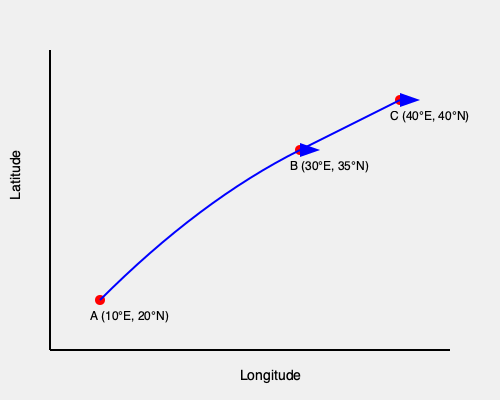As the director of a humanitarian organization, you're planning a mission to assist refugees along their migration route. The map shows three key locations: A (10°E, 20°N), B (30°E, 35°N), and C (40°E, 40°N). What is the total distance traveled by refugees following this route, assuming they move in straight lines between these points? (Use the Haversine formula and assume the Earth's radius is 6371 km. Round your answer to the nearest kilometer.) To solve this problem, we need to calculate the distances between points A and B, and then B and C using the Haversine formula. Then, we'll sum these distances to get the total route length.

The Haversine formula is:

$$d = 2r \arcsin(\sqrt{\sin^2(\frac{\Delta\phi}{2}) + \cos\phi_1 \cos\phi_2 \sin^2(\frac{\Delta\lambda}{2})})$$

Where:
- $r$ is the Earth's radius (6371 km)
- $\phi$ is latitude in radians
- $\lambda$ is longitude in radians

Step 1: Convert all coordinates from degrees to radians
A: (10°E, 20°N) → (0.1745 rad, 0.3491 rad)
B: (30°E, 35°N) → (0.5236 rad, 0.6109 rad)
C: (40°E, 40°N) → (0.6981 rad, 0.6981 rad)

Step 2: Calculate distance from A to B
$\Delta\phi = 0.6109 - 0.3491 = 0.2618$
$\Delta\lambda = 0.5236 - 0.1745 = 0.3491$

Applying the Haversine formula:
$$d_{AB} = 2 * 6371 * \arcsin(\sqrt{\sin^2(0.1309) + \cos(0.3491) \cos(0.6109) \sin^2(0.17455)})$$
$$d_{AB} \approx 2588.39 \text{ km}$$

Step 3: Calculate distance from B to C
$\Delta\phi = 0.6981 - 0.6109 = 0.0872$
$\Delta\lambda = 0.6981 - 0.5236 = 0.1745$

Applying the Haversine formula:
$$d_{BC} = 2 * 6371 * \arcsin(\sqrt{\sin^2(0.0436) + \cos(0.6109) \cos(0.6981) \sin^2(0.08725)})$$
$$d_{BC} \approx 1052.92 \text{ km}$$

Step 4: Calculate total distance
Total distance = $d_{AB} + d_{BC} = 2588.39 + 1052.92 = 3641.31 \text{ km}$

Rounding to the nearest kilometer: 3641 km
Answer: 3641 km 